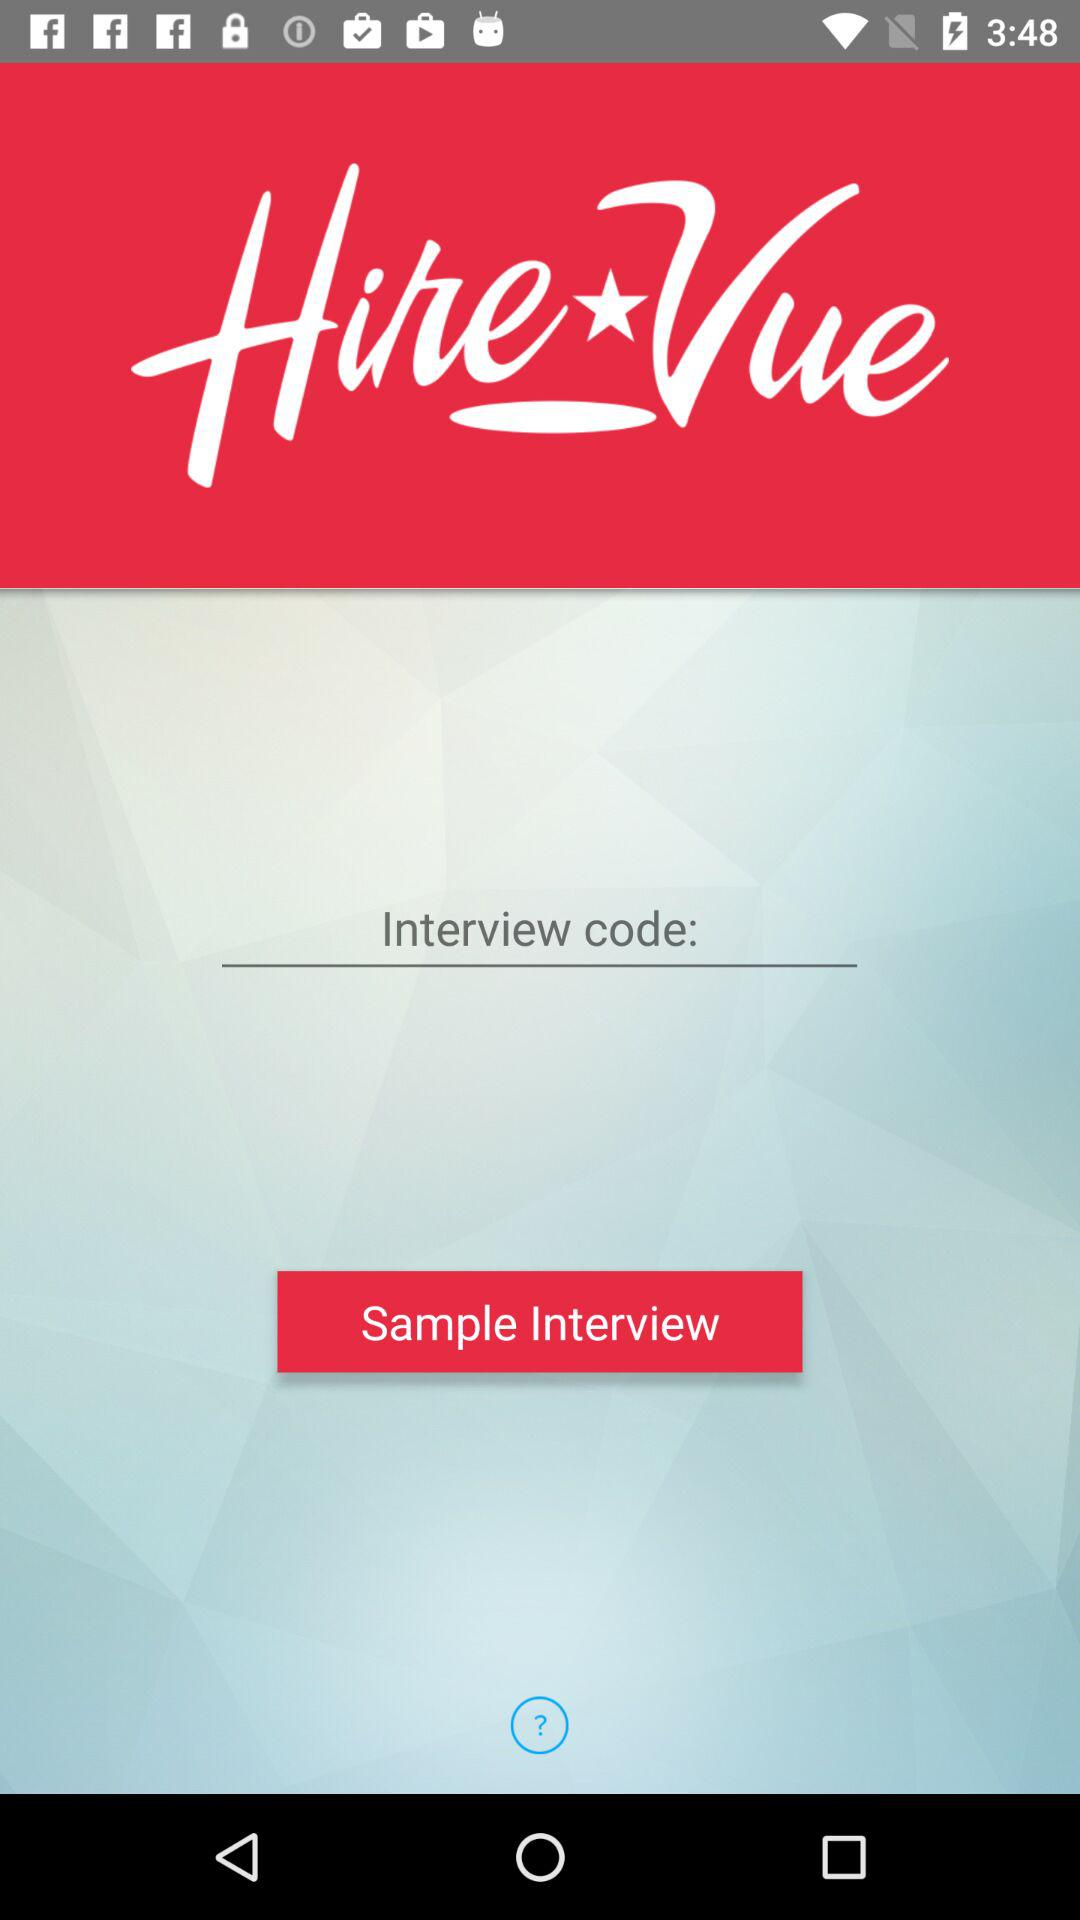What is the application name? The application name is "HireVue". 